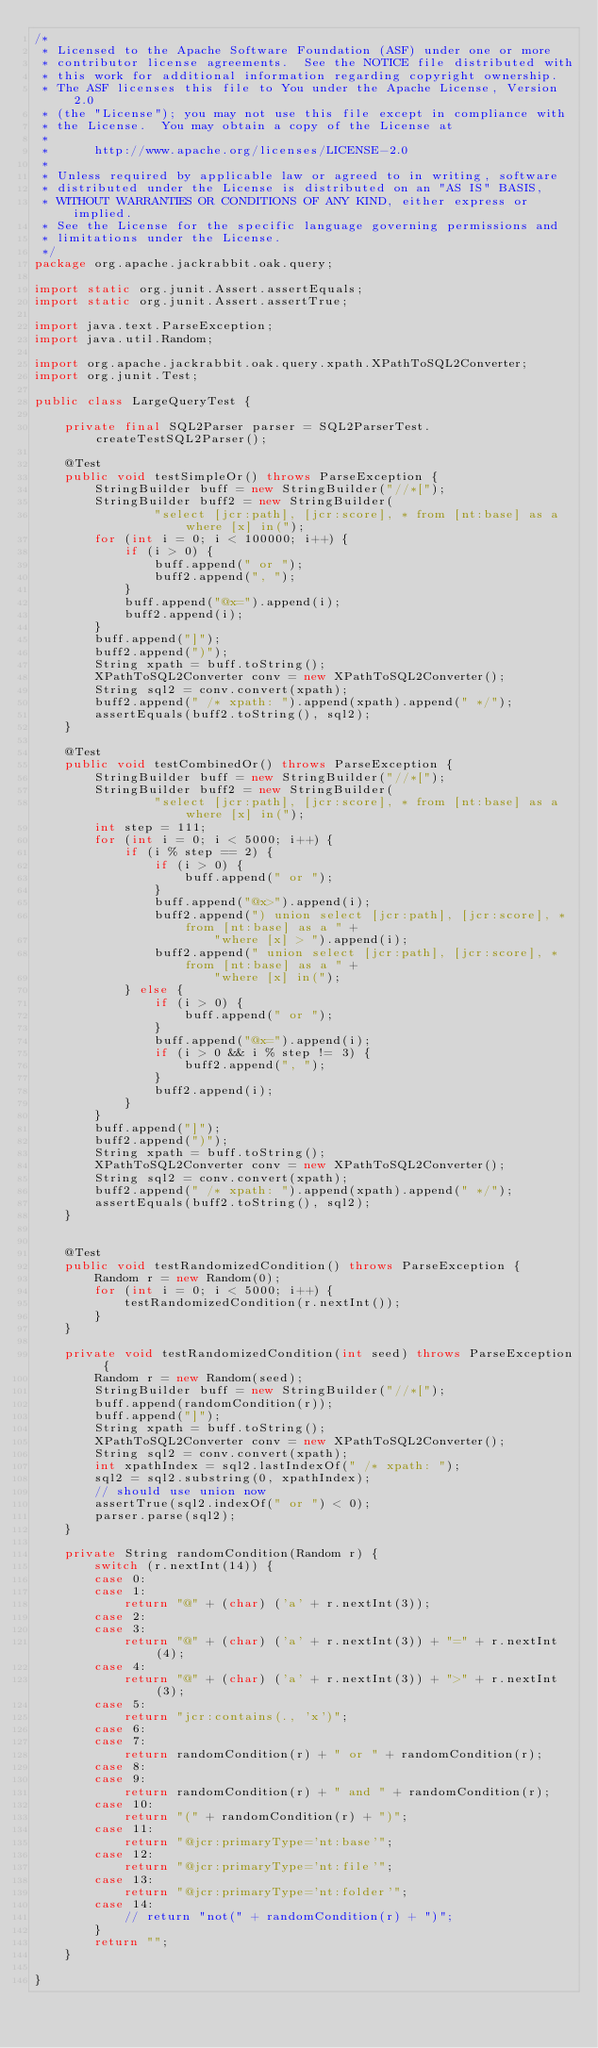Convert code to text. <code><loc_0><loc_0><loc_500><loc_500><_Java_>/*
 * Licensed to the Apache Software Foundation (ASF) under one or more
 * contributor license agreements.  See the NOTICE file distributed with
 * this work for additional information regarding copyright ownership.
 * The ASF licenses this file to You under the Apache License, Version 2.0
 * (the "License"); you may not use this file except in compliance with
 * the License.  You may obtain a copy of the License at
 *
 *      http://www.apache.org/licenses/LICENSE-2.0
 *
 * Unless required by applicable law or agreed to in writing, software
 * distributed under the License is distributed on an "AS IS" BASIS,
 * WITHOUT WARRANTIES OR CONDITIONS OF ANY KIND, either express or implied.
 * See the License for the specific language governing permissions and
 * limitations under the License.
 */
package org.apache.jackrabbit.oak.query;

import static org.junit.Assert.assertEquals;
import static org.junit.Assert.assertTrue;

import java.text.ParseException;
import java.util.Random;

import org.apache.jackrabbit.oak.query.xpath.XPathToSQL2Converter;
import org.junit.Test;

public class LargeQueryTest {
    
    private final SQL2Parser parser = SQL2ParserTest.createTestSQL2Parser();

    @Test
    public void testSimpleOr() throws ParseException {
        StringBuilder buff = new StringBuilder("//*[");
        StringBuilder buff2 = new StringBuilder(
                "select [jcr:path], [jcr:score], * from [nt:base] as a where [x] in(");
        for (int i = 0; i < 100000; i++) {
            if (i > 0) {
                buff.append(" or ");
                buff2.append(", ");
            }
            buff.append("@x=").append(i);
            buff2.append(i);
        }
        buff.append("]");
        buff2.append(")");
        String xpath = buff.toString();
        XPathToSQL2Converter conv = new XPathToSQL2Converter();
        String sql2 = conv.convert(xpath);
        buff2.append(" /* xpath: ").append(xpath).append(" */");
        assertEquals(buff2.toString(), sql2);
    }
    
    @Test
    public void testCombinedOr() throws ParseException {
        StringBuilder buff = new StringBuilder("//*[");
        StringBuilder buff2 = new StringBuilder(
                "select [jcr:path], [jcr:score], * from [nt:base] as a where [x] in(");
        int step = 111;
        for (int i = 0; i < 5000; i++) {
            if (i % step == 2) {
                if (i > 0) {
                    buff.append(" or ");
                }
                buff.append("@x>").append(i);
                buff2.append(") union select [jcr:path], [jcr:score], * from [nt:base] as a " + 
                        "where [x] > ").append(i);
                buff2.append(" union select [jcr:path], [jcr:score], * from [nt:base] as a " + 
                        "where [x] in(");
            } else {
                if (i > 0) {
                    buff.append(" or ");
                }
                buff.append("@x=").append(i);
                if (i > 0 && i % step != 3) {
                    buff2.append(", ");
                }
                buff2.append(i);
            }
        }
        buff.append("]");
        buff2.append(")");
        String xpath = buff.toString();
        XPathToSQL2Converter conv = new XPathToSQL2Converter();
        String sql2 = conv.convert(xpath);
        buff2.append(" /* xpath: ").append(xpath).append(" */");
        assertEquals(buff2.toString(), sql2);
    }
    
    
    @Test
    public void testRandomizedCondition() throws ParseException {
        Random r = new Random(0);
        for (int i = 0; i < 5000; i++) {
            testRandomizedCondition(r.nextInt());
        }
    }

    private void testRandomizedCondition(int seed) throws ParseException {
        Random r = new Random(seed);
        StringBuilder buff = new StringBuilder("//*[");
        buff.append(randomCondition(r));
        buff.append("]");
        String xpath = buff.toString();
        XPathToSQL2Converter conv = new XPathToSQL2Converter();
        String sql2 = conv.convert(xpath);
        int xpathIndex = sql2.lastIndexOf(" /* xpath: ");
        sql2 = sql2.substring(0, xpathIndex);
        // should use union now
        assertTrue(sql2.indexOf(" or ") < 0);
        parser.parse(sql2);
    }

    private String randomCondition(Random r) {
        switch (r.nextInt(14)) {
        case 0:
        case 1:
            return "@" + (char) ('a' + r.nextInt(3));
        case 2:
        case 3:
            return "@" + (char) ('a' + r.nextInt(3)) + "=" + r.nextInt(4);
        case 4:
            return "@" + (char) ('a' + r.nextInt(3)) + ">" + r.nextInt(3);
        case 5:
            return "jcr:contains(., 'x')";
        case 6:
        case 7:
            return randomCondition(r) + " or " + randomCondition(r);
        case 8:
        case 9:
            return randomCondition(r) + " and " + randomCondition(r);
        case 10:
            return "(" + randomCondition(r) + ")";
        case 11:
            return "@jcr:primaryType='nt:base'";
        case 12:
            return "@jcr:primaryType='nt:file'";
        case 13:
            return "@jcr:primaryType='nt:folder'";
        case 14:
            // return "not(" + randomCondition(r) + ")";
        }
        return "";
    }
    
}
</code> 